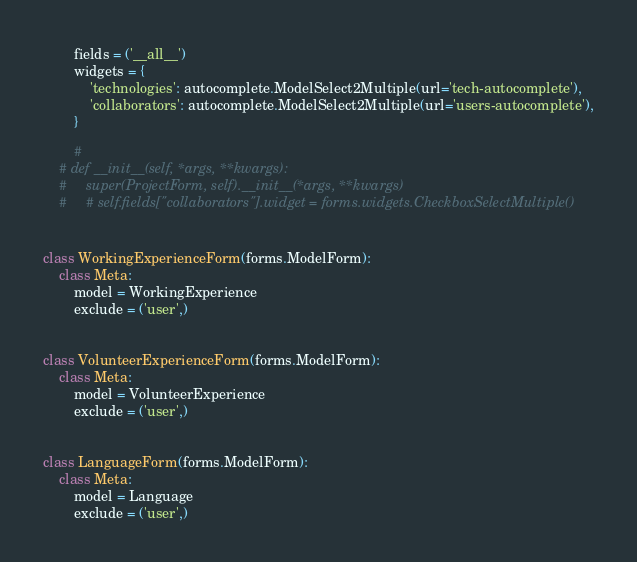<code> <loc_0><loc_0><loc_500><loc_500><_Python_>        fields = ('__all__')
        widgets = {
            'technologies': autocomplete.ModelSelect2Multiple(url='tech-autocomplete'),
            'collaborators': autocomplete.ModelSelect2Multiple(url='users-autocomplete'),
        }

        #
    # def __init__(self, *args, **kwargs):
    #     super(ProjectForm, self).__init__(*args, **kwargs)
    #     # self.fields["collaborators"].widget = forms.widgets.CheckboxSelectMultiple()


class WorkingExperienceForm(forms.ModelForm):
    class Meta:
        model = WorkingExperience
        exclude = ('user',)


class VolunteerExperienceForm(forms.ModelForm):
    class Meta:
        model = VolunteerExperience
        exclude = ('user',)


class LanguageForm(forms.ModelForm):
    class Meta:
        model = Language
        exclude = ('user',)
</code> 